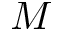<formula> <loc_0><loc_0><loc_500><loc_500>M</formula> 